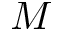<formula> <loc_0><loc_0><loc_500><loc_500>M</formula> 